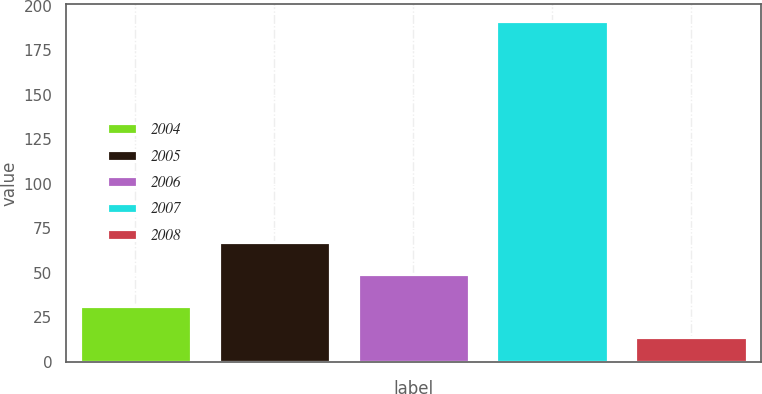Convert chart. <chart><loc_0><loc_0><loc_500><loc_500><bar_chart><fcel>2004<fcel>2005<fcel>2006<fcel>2007<fcel>2008<nl><fcel>31.46<fcel>66.98<fcel>49.22<fcel>191.3<fcel>13.7<nl></chart> 